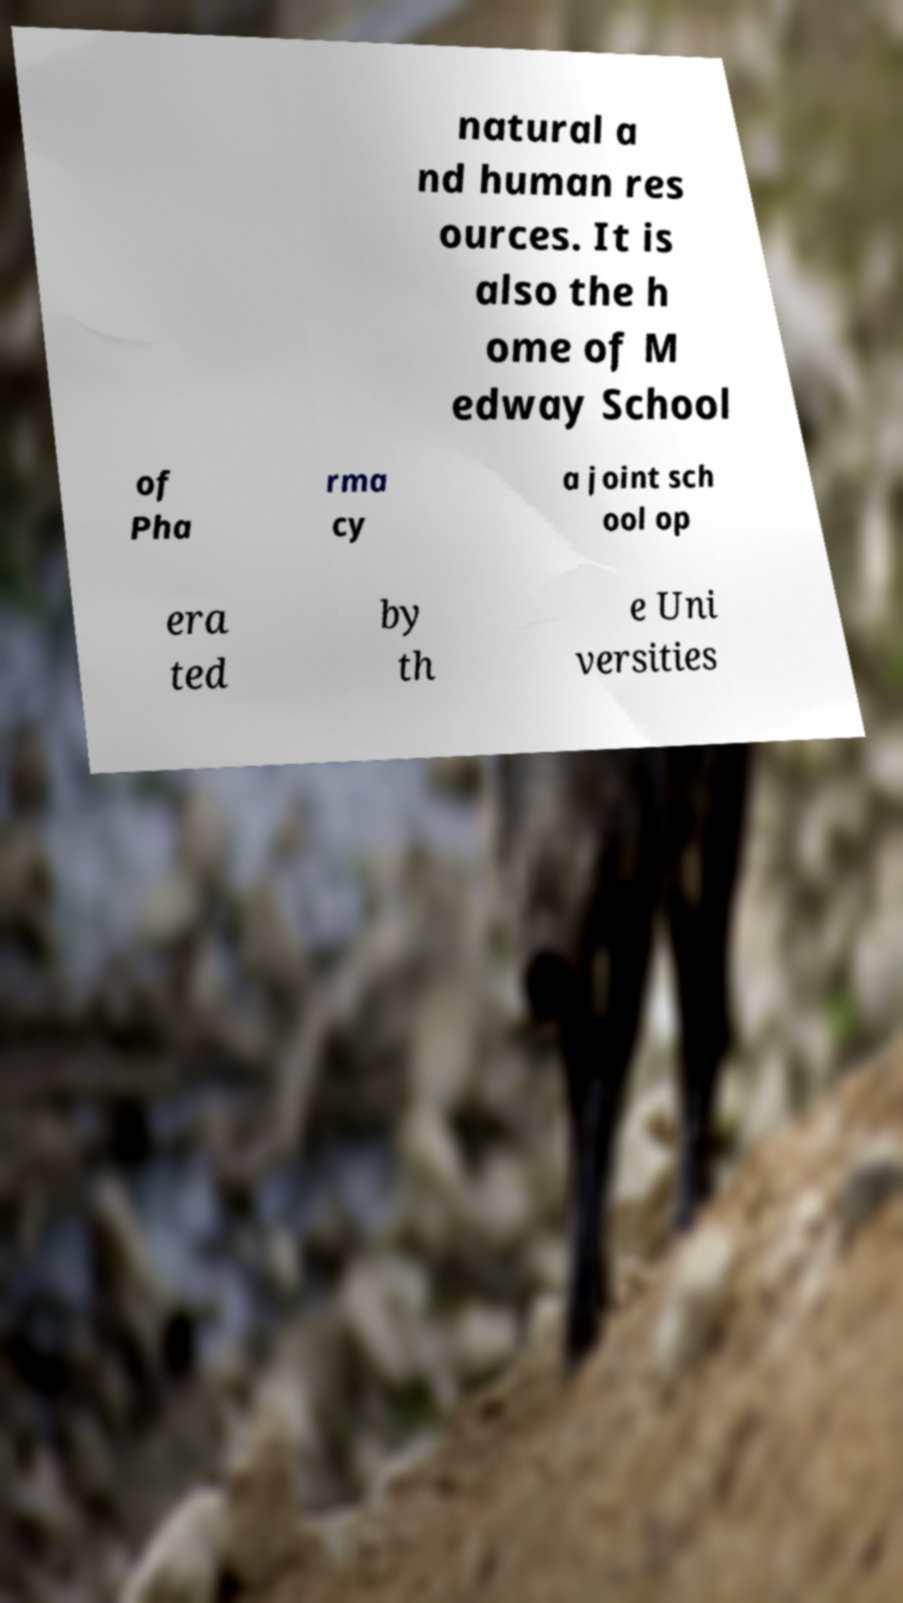Can you read and provide the text displayed in the image?This photo seems to have some interesting text. Can you extract and type it out for me? natural a nd human res ources. It is also the h ome of M edway School of Pha rma cy a joint sch ool op era ted by th e Uni versities 